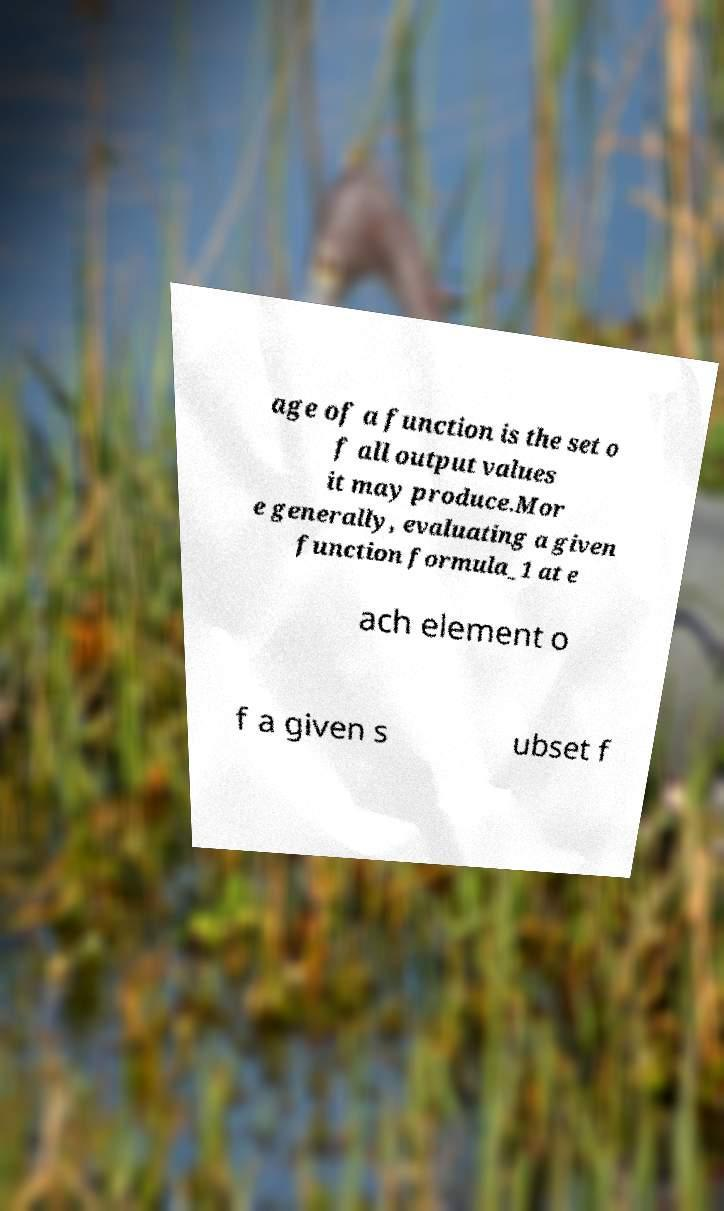Could you extract and type out the text from this image? age of a function is the set o f all output values it may produce.Mor e generally, evaluating a given function formula_1 at e ach element o f a given s ubset f 